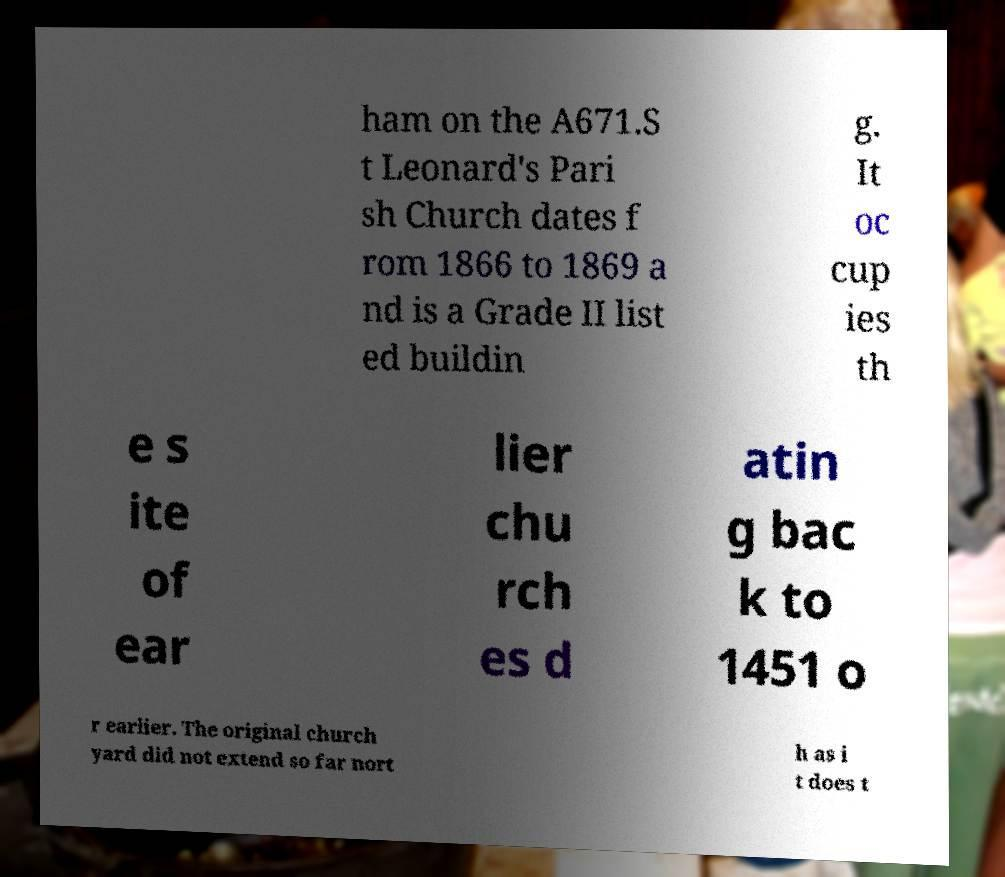What messages or text are displayed in this image? I need them in a readable, typed format. ham on the A671.S t Leonard's Pari sh Church dates f rom 1866 to 1869 a nd is a Grade II list ed buildin g. It oc cup ies th e s ite of ear lier chu rch es d atin g bac k to 1451 o r earlier. The original church yard did not extend so far nort h as i t does t 